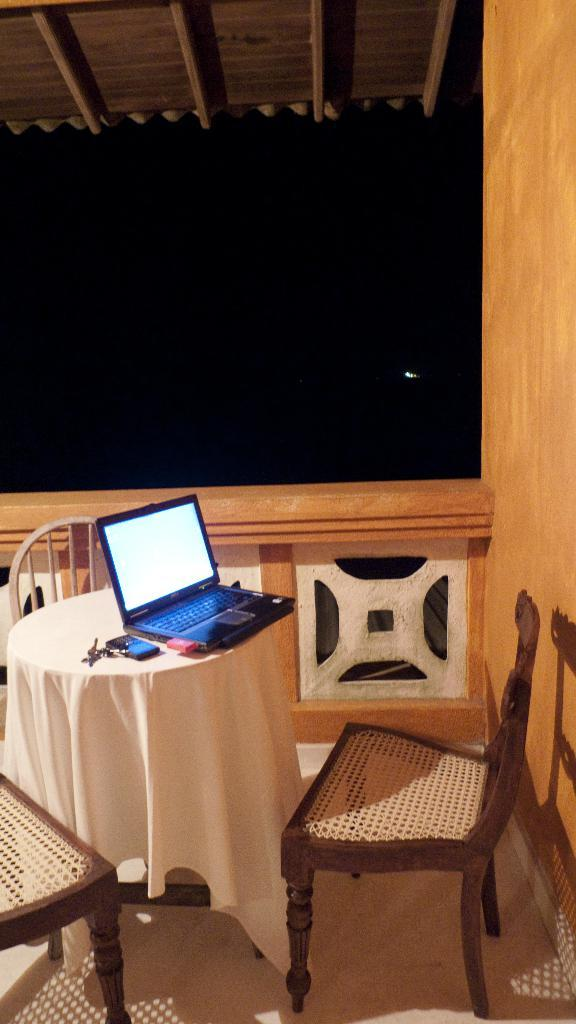What electronic device is on the table in the image? There is a laptop on the table in the image. How many chairs are around the table? There are three chairs around the table. What type of committee is meeting around the table in the image? There is no committee meeting in the image; it only shows a laptop on the table and three chairs around it. 